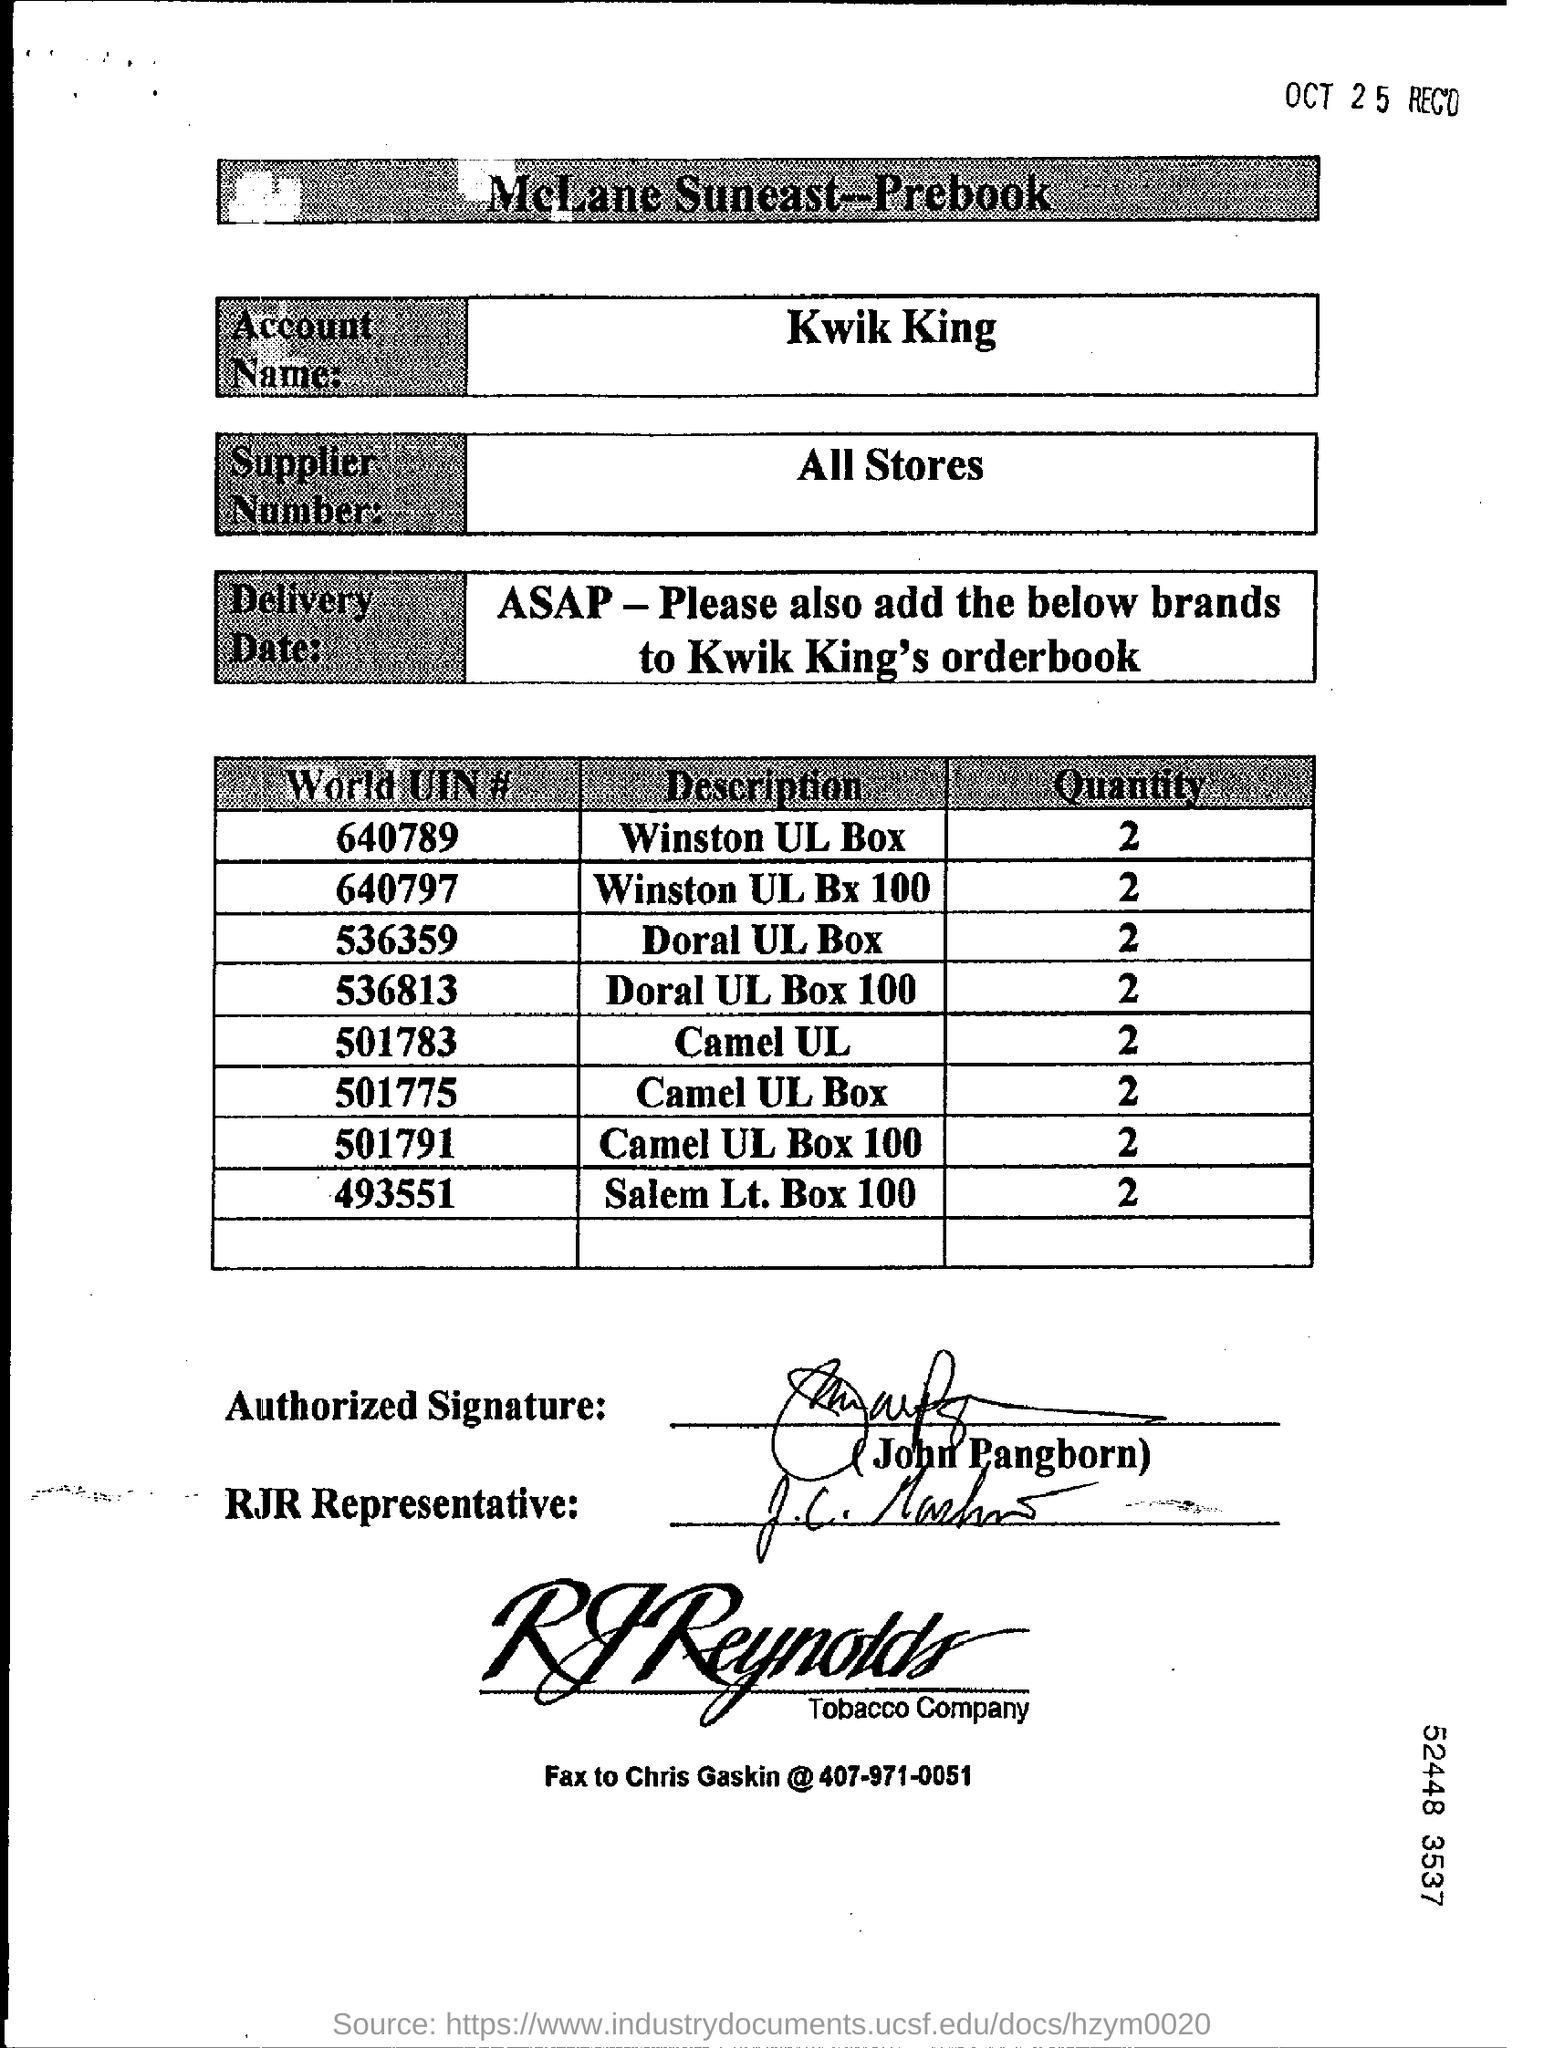What is the Account Name ?
Offer a terse response. Kwik King. What is written in the Supplier Number Field ?
Offer a terse response. All stores. What is the Quantity of Winston UL Box ?
Provide a succinct answer. 2. What is the World UIN Number of Winston UL Bx 100 ?
Give a very brief answer. 640797. What is the Fax Number ?
Offer a very short reply. 407-971-0051. What is the Quantity of Camel UL ?
Make the answer very short. 2. What is the World UIN Number of Camel UL Box 100 ?
Offer a very short reply. 501791. What is the World UIN Number of Doral UL Box ?
Give a very brief answer. 536359. 